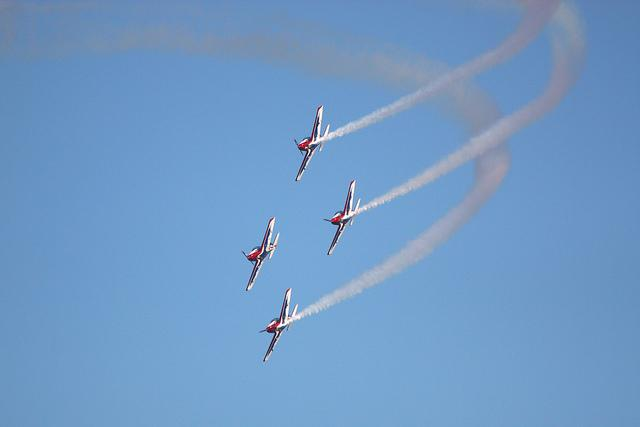The planes are executing a what? Please explain your reasoning. stunt formation. They have smoke coming out the back and are in formation doing tricks 